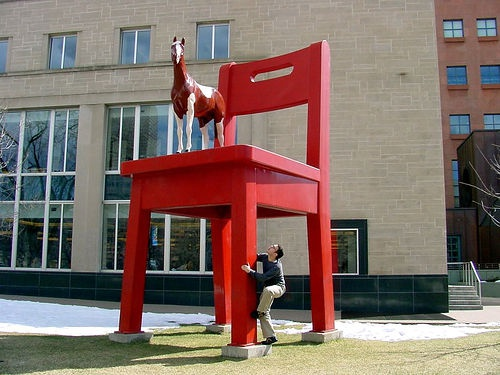Describe the objects in this image and their specific colors. I can see chair in gray, maroon, darkgray, and salmon tones, horse in gray, maroon, white, darkgray, and black tones, and people in gray, black, and white tones in this image. 